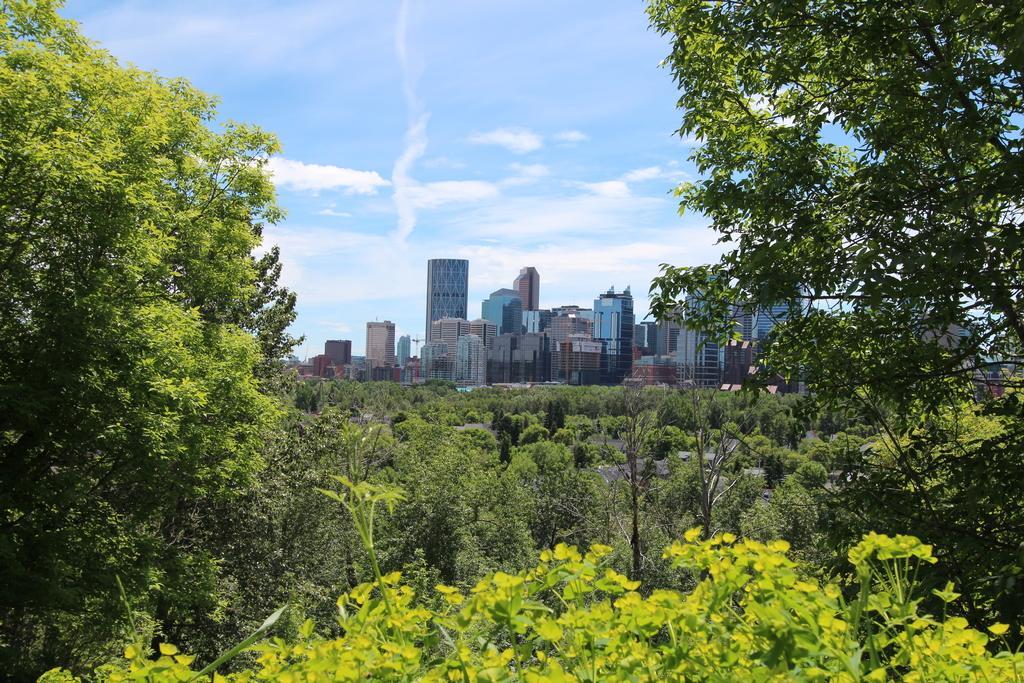Describe this image in one or two sentences. In this picture we can see trees and buildings and in the background we can see sky with clouds. 